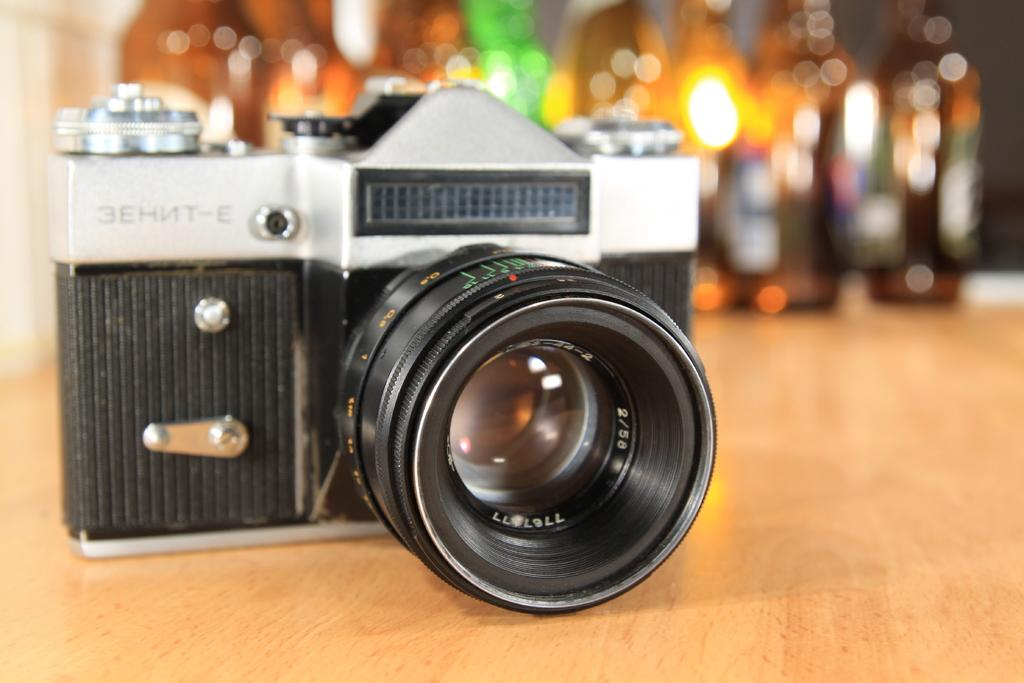What object is the main subject of the image? There is a camera in the image. What colors can be seen on the camera? The camera is black and silver in color. Can you describe the background of the image? The background of the image is blurry. What type of picture is hanging on the wall in the image? There is no picture hanging on the wall in the image; it only features a camera. Can you describe the ray of light coming from the camera in the image? There is no ray of light coming from the camera in the image; it is a still object. 